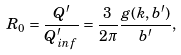Convert formula to latex. <formula><loc_0><loc_0><loc_500><loc_500>R _ { 0 } = \frac { Q ^ { \prime } } { Q _ { i n f } ^ { \prime } } = \frac { 3 } { 2 \pi } \frac { g ( k , b ^ { \prime } ) } { b ^ { \prime } } ,</formula> 